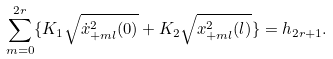<formula> <loc_0><loc_0><loc_500><loc_500>\sum _ { m = 0 } ^ { 2 r } \{ K _ { 1 } \sqrt { \dot { x } _ { + m l } ^ { 2 } ( 0 ) } + K _ { 2 } \sqrt { x _ { + m l } ^ { 2 } ( l ) } \} = h _ { 2 r + 1 } .</formula> 